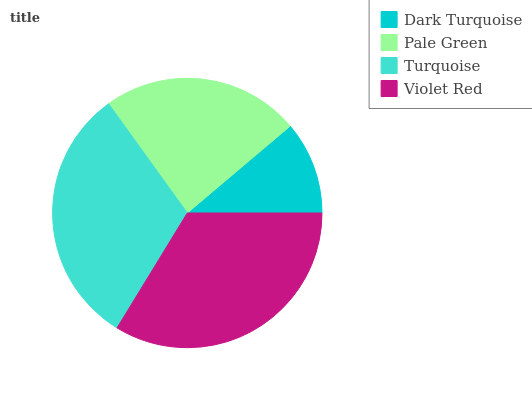Is Dark Turquoise the minimum?
Answer yes or no. Yes. Is Violet Red the maximum?
Answer yes or no. Yes. Is Pale Green the minimum?
Answer yes or no. No. Is Pale Green the maximum?
Answer yes or no. No. Is Pale Green greater than Dark Turquoise?
Answer yes or no. Yes. Is Dark Turquoise less than Pale Green?
Answer yes or no. Yes. Is Dark Turquoise greater than Pale Green?
Answer yes or no. No. Is Pale Green less than Dark Turquoise?
Answer yes or no. No. Is Turquoise the high median?
Answer yes or no. Yes. Is Pale Green the low median?
Answer yes or no. Yes. Is Dark Turquoise the high median?
Answer yes or no. No. Is Violet Red the low median?
Answer yes or no. No. 